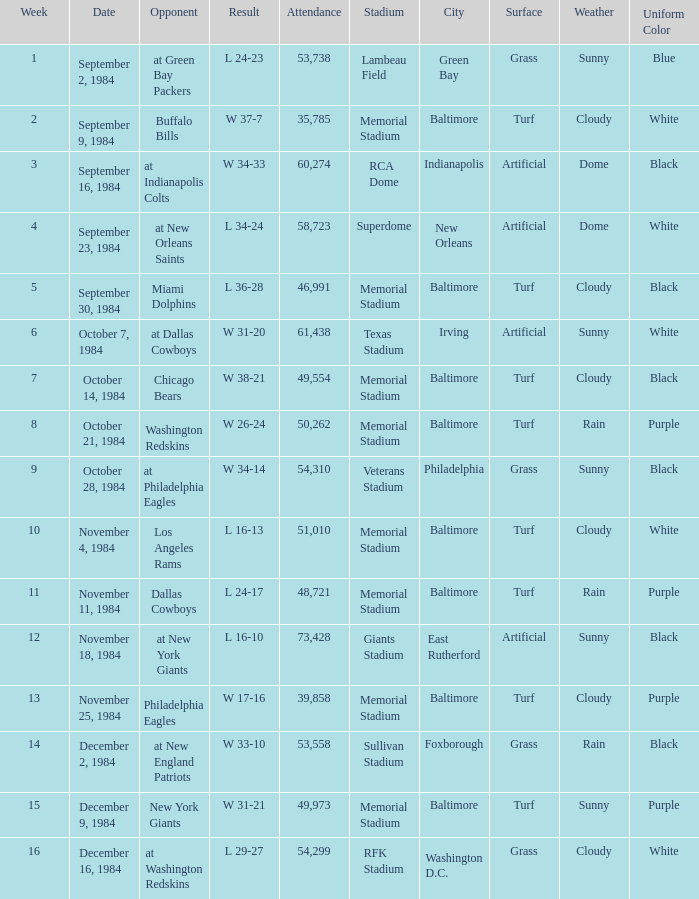Who was the opponent on October 14, 1984? Chicago Bears. Help me parse the entirety of this table. {'header': ['Week', 'Date', 'Opponent', 'Result', 'Attendance', 'Stadium', 'City', 'Surface', 'Weather', 'Uniform Color'], 'rows': [['1', 'September 2, 1984', 'at Green Bay Packers', 'L 24-23', '53,738', 'Lambeau Field', 'Green Bay', 'Grass', 'Sunny', 'Blue'], ['2', 'September 9, 1984', 'Buffalo Bills', 'W 37-7', '35,785', 'Memorial Stadium', 'Baltimore', 'Turf', 'Cloudy', 'White'], ['3', 'September 16, 1984', 'at Indianapolis Colts', 'W 34-33', '60,274', 'RCA Dome', 'Indianapolis', 'Artificial', 'Dome', 'Black'], ['4', 'September 23, 1984', 'at New Orleans Saints', 'L 34-24', '58,723', 'Superdome', 'New Orleans', 'Artificial', 'Dome', 'White'], ['5', 'September 30, 1984', 'Miami Dolphins', 'L 36-28', '46,991', 'Memorial Stadium', 'Baltimore', 'Turf', 'Cloudy', 'Black'], ['6', 'October 7, 1984', 'at Dallas Cowboys', 'W 31-20', '61,438', 'Texas Stadium', 'Irving', 'Artificial', 'Sunny', 'White'], ['7', 'October 14, 1984', 'Chicago Bears', 'W 38-21', '49,554', 'Memorial Stadium', 'Baltimore', 'Turf', 'Cloudy', 'Black'], ['8', 'October 21, 1984', 'Washington Redskins', 'W 26-24', '50,262', 'Memorial Stadium', 'Baltimore', 'Turf', 'Rain', 'Purple'], ['9', 'October 28, 1984', 'at Philadelphia Eagles', 'W 34-14', '54,310', 'Veterans Stadium', 'Philadelphia', 'Grass', 'Sunny', 'Black'], ['10', 'November 4, 1984', 'Los Angeles Rams', 'L 16-13', '51,010', 'Memorial Stadium', 'Baltimore', 'Turf', 'Cloudy', 'White'], ['11', 'November 11, 1984', 'Dallas Cowboys', 'L 24-17', '48,721', 'Memorial Stadium', 'Baltimore', 'Turf', 'Rain', 'Purple'], ['12', 'November 18, 1984', 'at New York Giants', 'L 16-10', '73,428', 'Giants Stadium', 'East Rutherford', 'Artificial', 'Sunny', 'Black'], ['13', 'November 25, 1984', 'Philadelphia Eagles', 'W 17-16', '39,858', 'Memorial Stadium', 'Baltimore', 'Turf', 'Cloudy', 'Purple'], ['14', 'December 2, 1984', 'at New England Patriots', 'W 33-10', '53,558', 'Sullivan Stadium', 'Foxborough', 'Grass', 'Rain', 'Black'], ['15', 'December 9, 1984', 'New York Giants', 'W 31-21', '49,973', 'Memorial Stadium', 'Baltimore', 'Turf', 'Sunny', 'Purple'], ['16', 'December 16, 1984', 'at Washington Redskins', 'L 29-27', '54,299', 'RFK Stadium', 'Washington D.C.', 'Grass', 'Cloudy', 'White']]} 